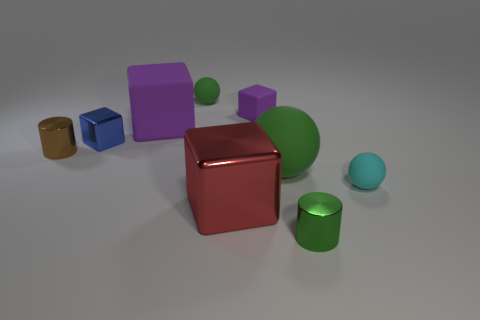Add 1 tiny green rubber cylinders. How many objects exist? 10 Subtract all blocks. How many objects are left? 5 Add 6 red metallic blocks. How many red metallic blocks exist? 7 Subtract 0 red cylinders. How many objects are left? 9 Subtract all cyan objects. Subtract all tiny gray metal objects. How many objects are left? 8 Add 7 large things. How many large things are left? 10 